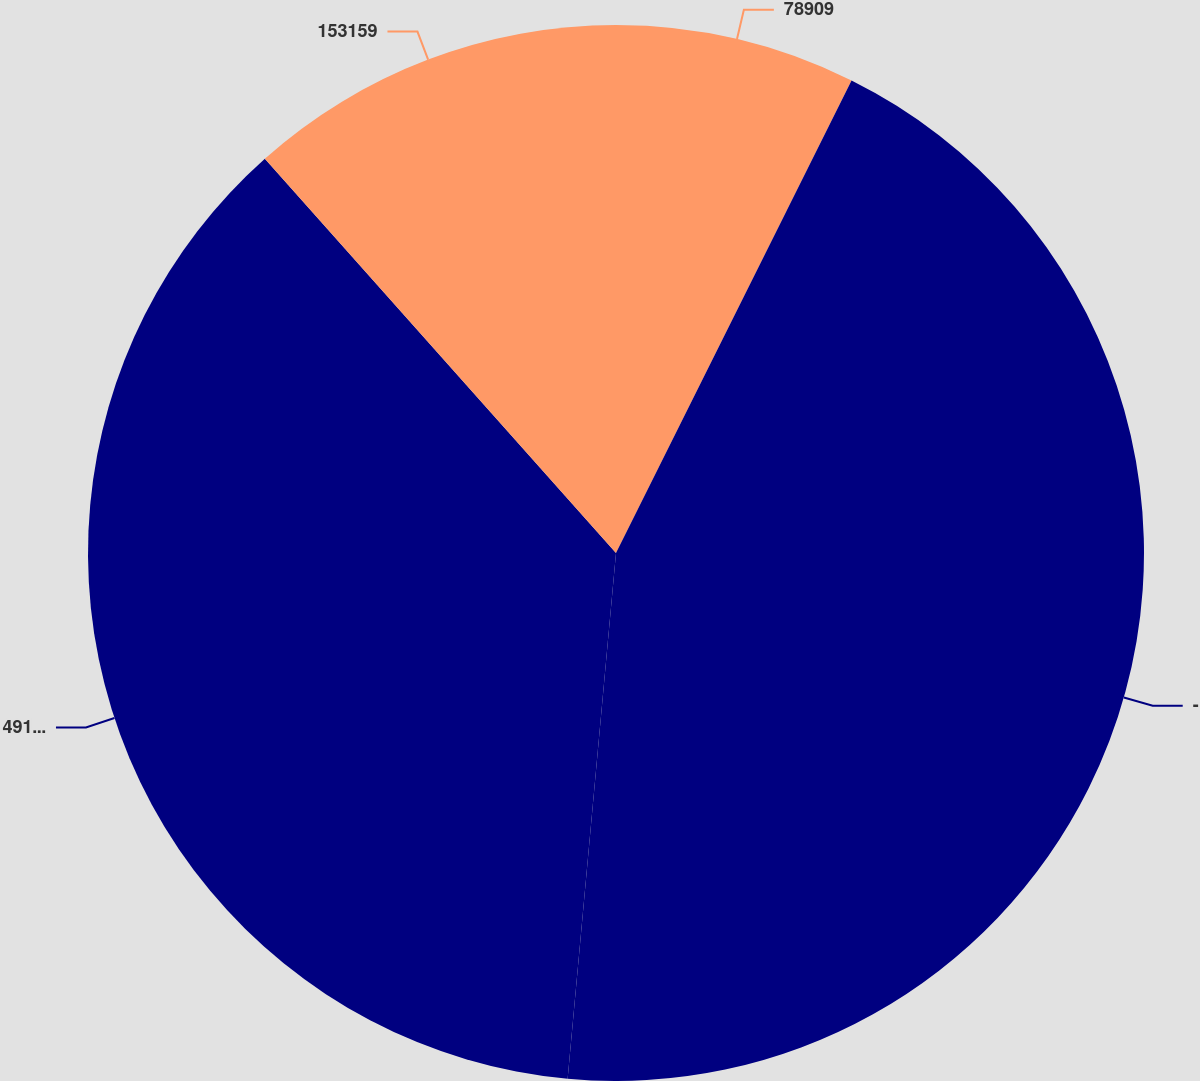Convert chart. <chart><loc_0><loc_0><loc_500><loc_500><pie_chart><fcel>78909<fcel>-<fcel>49142<fcel>153159<nl><fcel>7.36%<fcel>44.1%<fcel>36.96%<fcel>11.58%<nl></chart> 